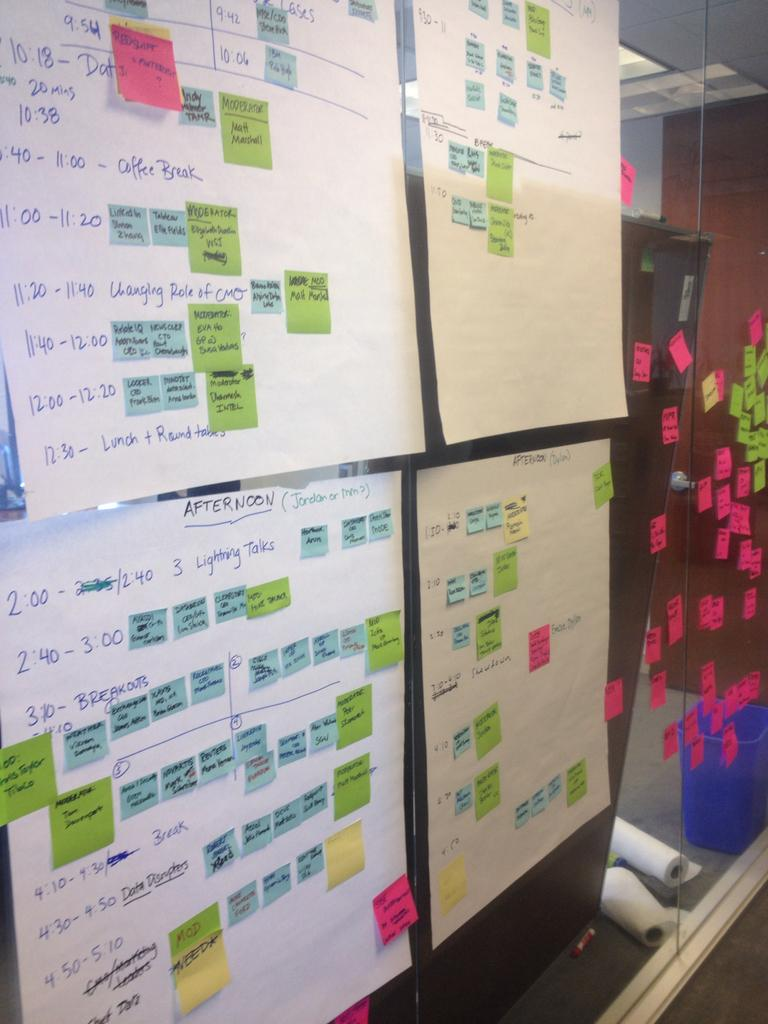<image>
Describe the image concisely. Several schedules on a wall with the 3:10 slot named Breakouts. 